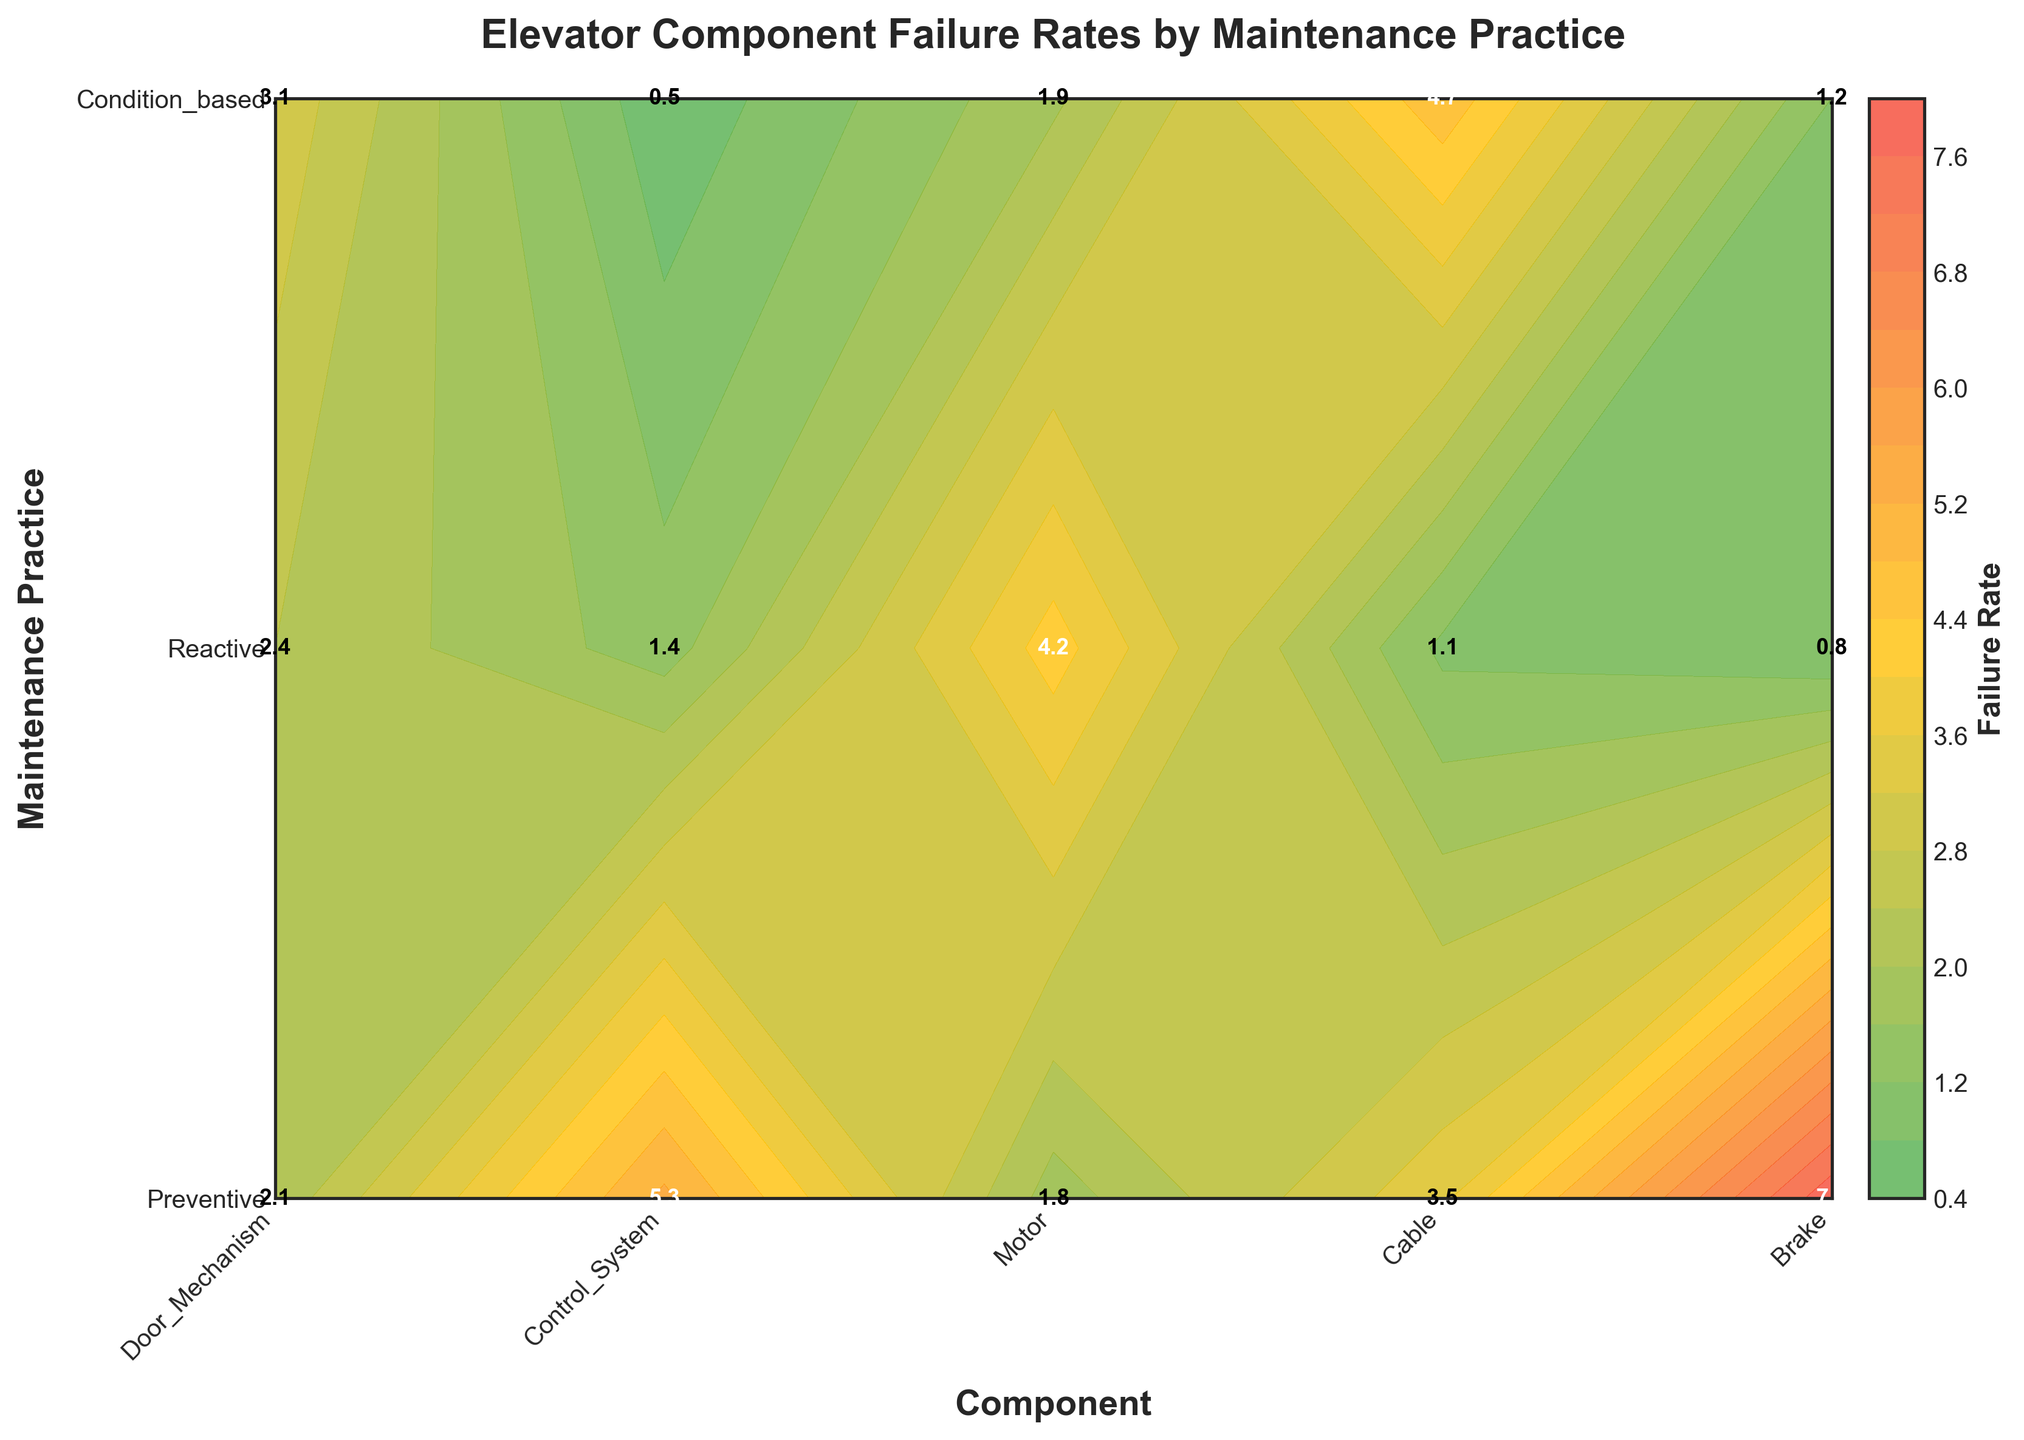What is the title of the plot? The title appears at the top of the plot and typically summarizes what the plot is about.
Answer: Elevator Component Failure Rates by Maintenance Practice Which maintenance practice has the highest failure rate for the Control System? The highest failure rate can be found by looking for the darkest red color in the "Control System" column. The corresponding label on the y-axis (maintenance practice) is "Reactive".
Answer: Reactive What is the failure rate for the Cable with Condition-based maintenance? Locate the "Cable" in the x-axis and "Condition-based" in the y-axis. The number labeled in the cell at their intersection shows the failure rate.
Answer: 0.5 Which component has the lowest failure rate with reactive maintenance? In the row labeled "Reactive" on the y-axis, look for the lightest color corresponding to the lowest number. The x-axis then indicates the component.
Answer: Cable What is the average failure rate for Door Mechanism across all maintenance practices? Identify the failure rates for the Door Mechanism: 2.1 (Preventive), 5.3 (Reactive), and 1.8 (Condition-based). Add these together and divide by the number of data points (3). (2.1+5.3+1.8)/3 = 3.07
Answer: 3.07 Which maintenance practice generally results in the highest failure rates across all components? Compare the colors across each row corresponding to the maintenance practices. The row with the most dark red cells indicates the highest failure rates.
Answer: Reactive Between Condition-based and Preventive maintenance practices, which generally leads to lower failure rates? Compare the colors (green to red gradient) and numbers in the rows for Condition-based and Preventive practices. The row with more green cells and lower numbers signifies lower failure rates.
Answer: Condition-based How do the failure rates of the Brake compare between Preventive and Reactive maintenance practices? Locate the corresponding cells for Brake in both Preventive and Reactive rows. The failure rates are: Preventive - 1.9 and Reactive - 4.7.
Answer: 1.9 (Preventive) is less than 4.7 (Reactive) What is the combined failure rate for Control System under Preventive and Condition-based maintenance practices? Add the failure rates for Control System under Preventive (3.5) and Condition-based (2.4) maintenance practices. 3.5 + 2.4 = 5.9
Answer: 5.9 